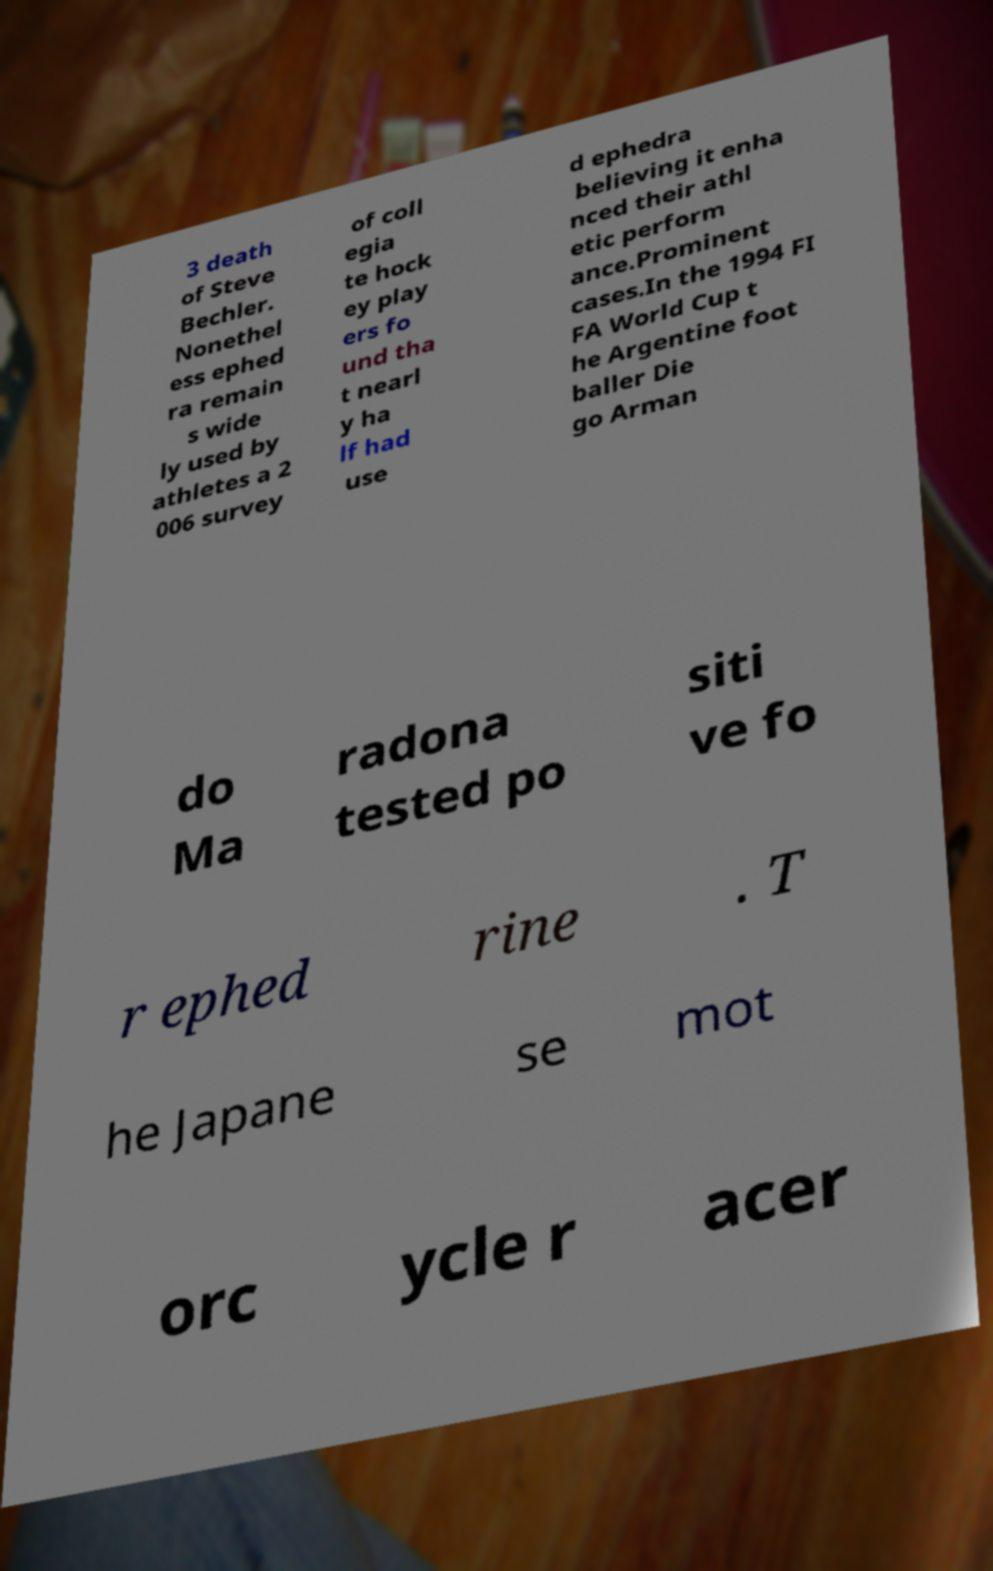Please read and relay the text visible in this image. What does it say? 3 death of Steve Bechler. Nonethel ess ephed ra remain s wide ly used by athletes a 2 006 survey of coll egia te hock ey play ers fo und tha t nearl y ha lf had use d ephedra believing it enha nced their athl etic perform ance.Prominent cases.In the 1994 FI FA World Cup t he Argentine foot baller Die go Arman do Ma radona tested po siti ve fo r ephed rine . T he Japane se mot orc ycle r acer 